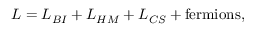Convert formula to latex. <formula><loc_0><loc_0><loc_500><loc_500>L = L _ { B I } + L _ { H M } + L _ { C S } + f e r m i o n s ,</formula> 